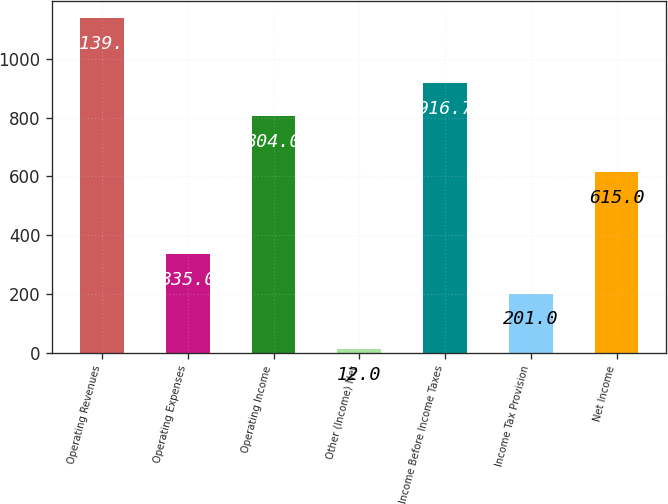Convert chart to OTSL. <chart><loc_0><loc_0><loc_500><loc_500><bar_chart><fcel>Operating Revenues<fcel>Operating Expenses<fcel>Operating Income<fcel>Other (Income) Net<fcel>Income Before Income Taxes<fcel>Income Tax Provision<fcel>Net Income<nl><fcel>1139<fcel>335<fcel>804<fcel>12<fcel>916.7<fcel>201<fcel>615<nl></chart> 